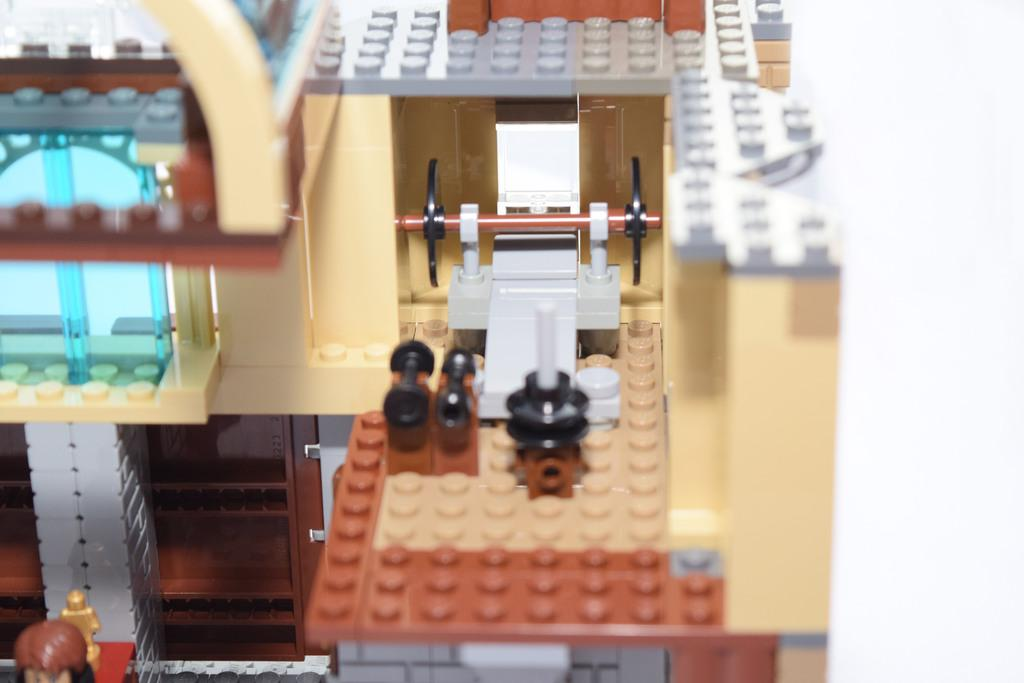What type of game is visible in the image? There is a lego game in the image. How many frogs can be seen hopping on the hill in the image? There are no frogs or hills present in the image; it features a lego game. What type of locket is hanging from the lego game in the image? There is no locket present in the image; it features a lego game. 